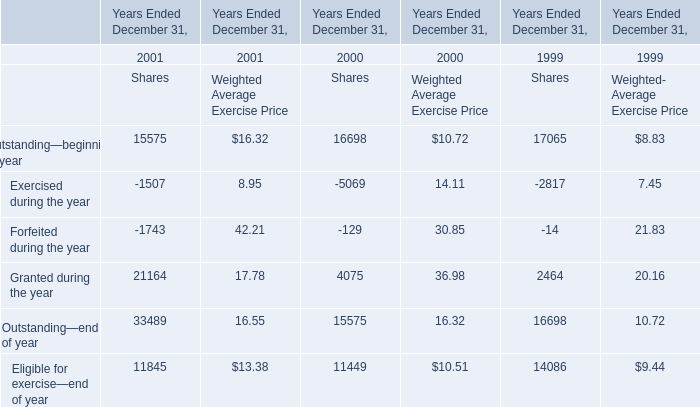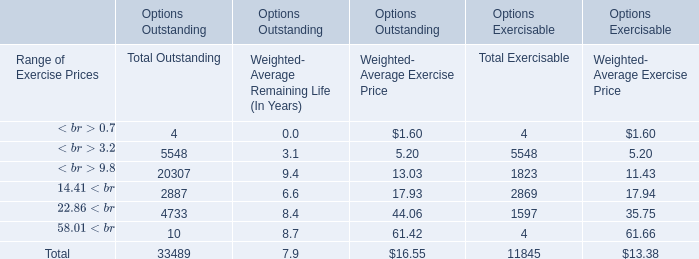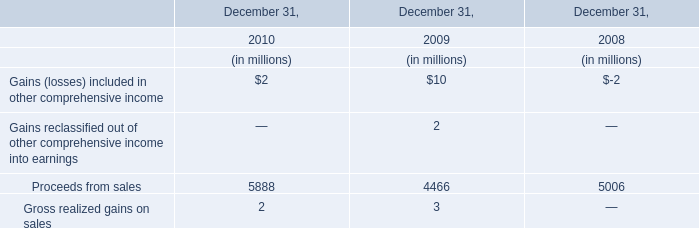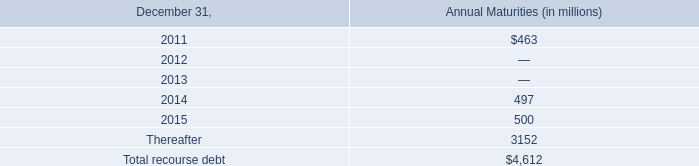what is the annual interest cost savings by the company redeeming the 8.75% ( 8.75 % ) second priority senior secured notes? 
Computations: ((690 * 1000000) * 8.75%)
Answer: 60375000.0. 